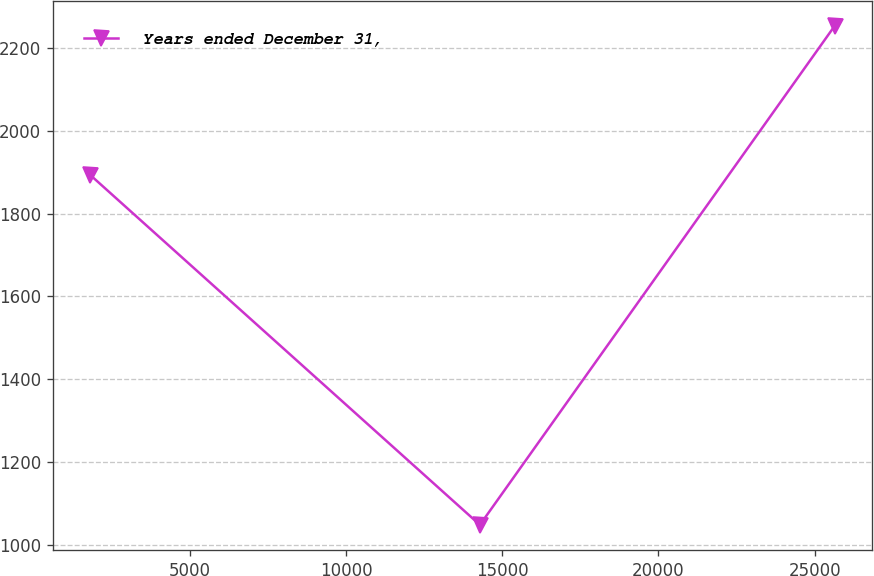Convert chart to OTSL. <chart><loc_0><loc_0><loc_500><loc_500><line_chart><ecel><fcel>Years ended December 31,<nl><fcel>1797.77<fcel>1893.94<nl><fcel>14284.3<fcel>1047.7<nl><fcel>25643.2<fcel>2253.44<nl></chart> 